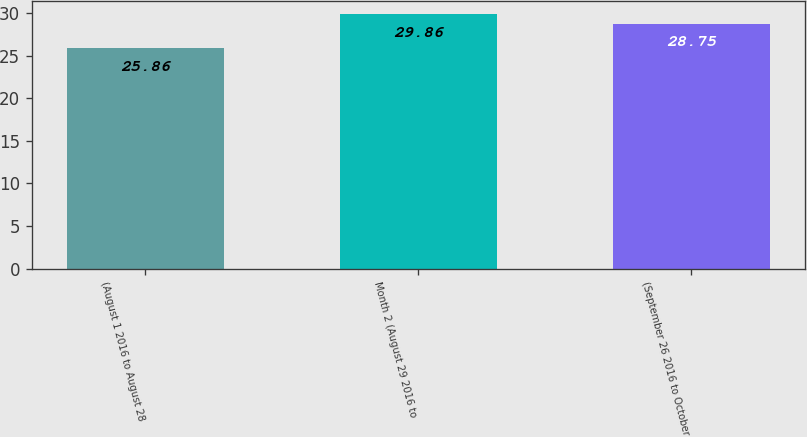Convert chart to OTSL. <chart><loc_0><loc_0><loc_500><loc_500><bar_chart><fcel>(August 1 2016 to August 28<fcel>Month 2 (August 29 2016 to<fcel>(September 26 2016 to October<nl><fcel>25.86<fcel>29.86<fcel>28.75<nl></chart> 